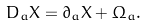<formula> <loc_0><loc_0><loc_500><loc_500>D _ { a } X = \partial _ { a } X + \Omega _ { a } .</formula> 